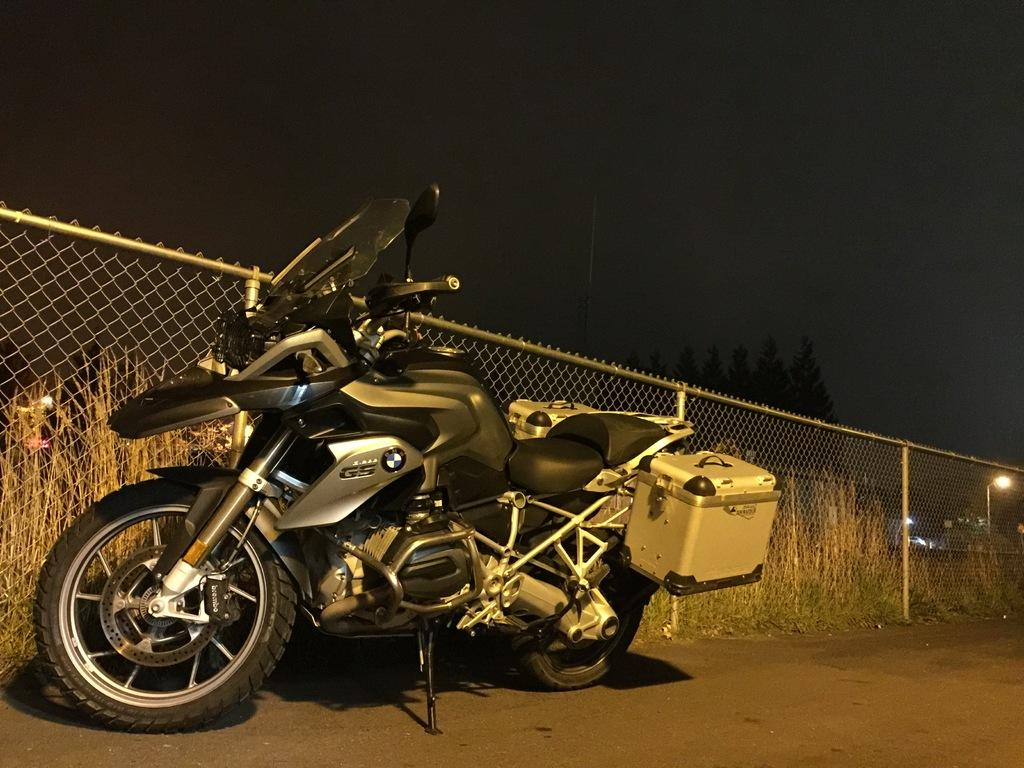What is the lighting condition in the image? The image was taken in the dark. What can be seen on the road in the image? There is a bike on the road. What is located behind the bike in the image? There is a net fencing at the back of the bike. What type of vegetation is near the net fencing? There are plants near the net fencing. What is the source of light on the right side of the image? There is a street light on the right side of the image. Where is the market located in the image? There is no market present in the image. What type of toys can be seen near the bike in the image? There are no toys visible in the image; only the bike, net fencing, plants, and street light are present. 